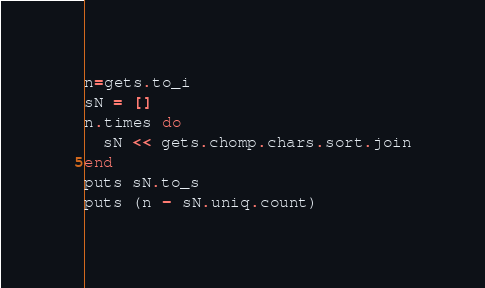<code> <loc_0><loc_0><loc_500><loc_500><_Ruby_>n=gets.to_i
sN = []
n.times do
  sN << gets.chomp.chars.sort.join
end
puts sN.to_s
puts (n - sN.uniq.count)</code> 